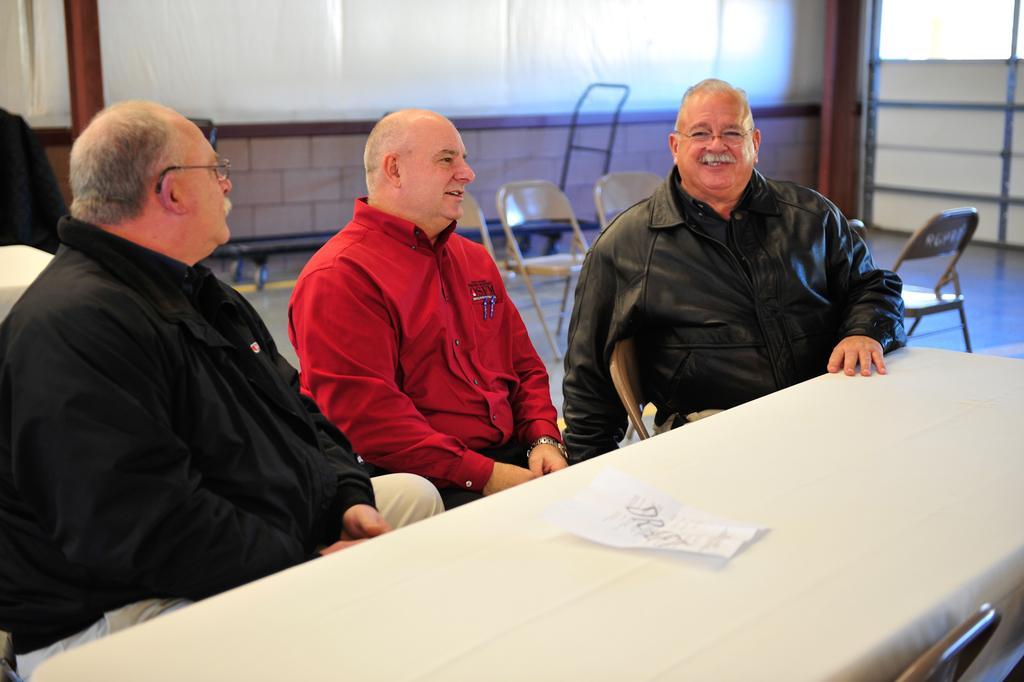How would you summarize this image in a sentence or two? On the background we can see a white board, empty chairs. This is a floor. Here we can see three men sitting on chair in front of a table and on the table we can see a paper. 